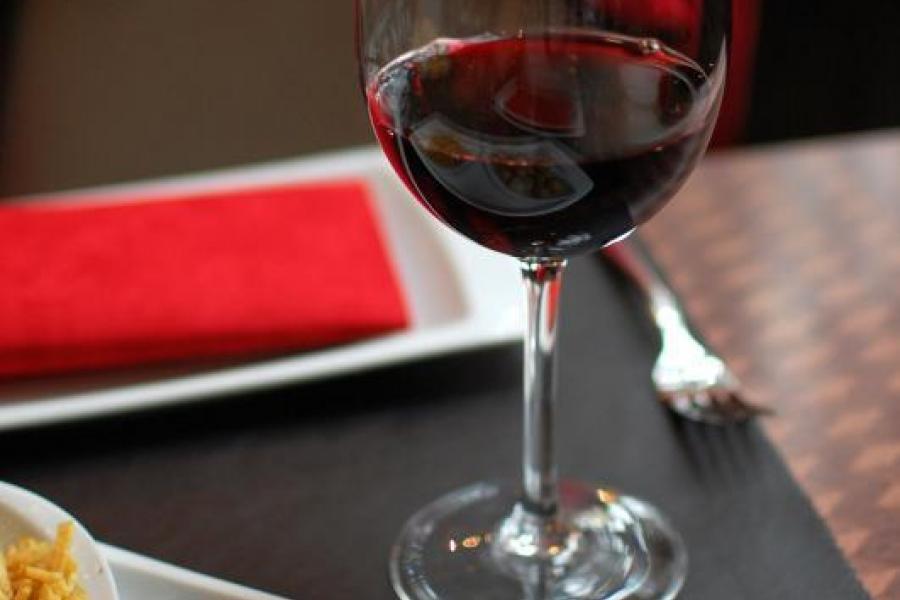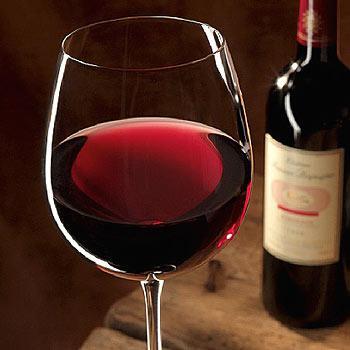The first image is the image on the left, the second image is the image on the right. Examine the images to the left and right. Is the description "Wine is pouring from a bottle into a glass in the left image." accurate? Answer yes or no. No. The first image is the image on the left, the second image is the image on the right. Given the left and right images, does the statement "In one of the images, red wine is being poured into a wine glass" hold true? Answer yes or no. No. 